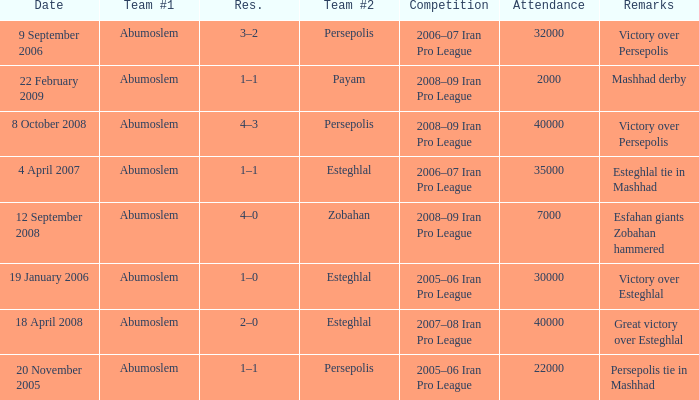What day had an attendance of 22,000? 20 November 2005. 